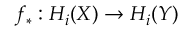<formula> <loc_0><loc_0><loc_500><loc_500>f _ { * } \colon H _ { i } ( X ) \to H _ { i } ( Y )</formula> 